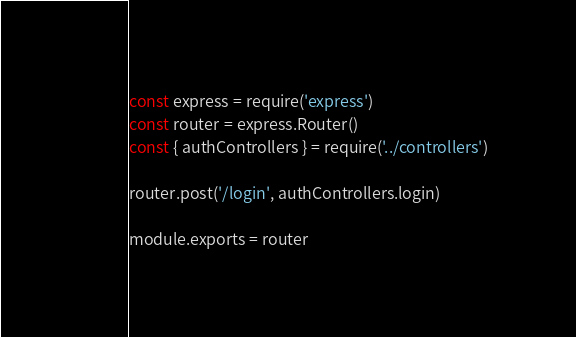Convert code to text. <code><loc_0><loc_0><loc_500><loc_500><_JavaScript_>const express = require('express')
const router = express.Router()
const { authControllers } = require('../controllers')

router.post('/login', authControllers.login)

module.exports = router
</code> 